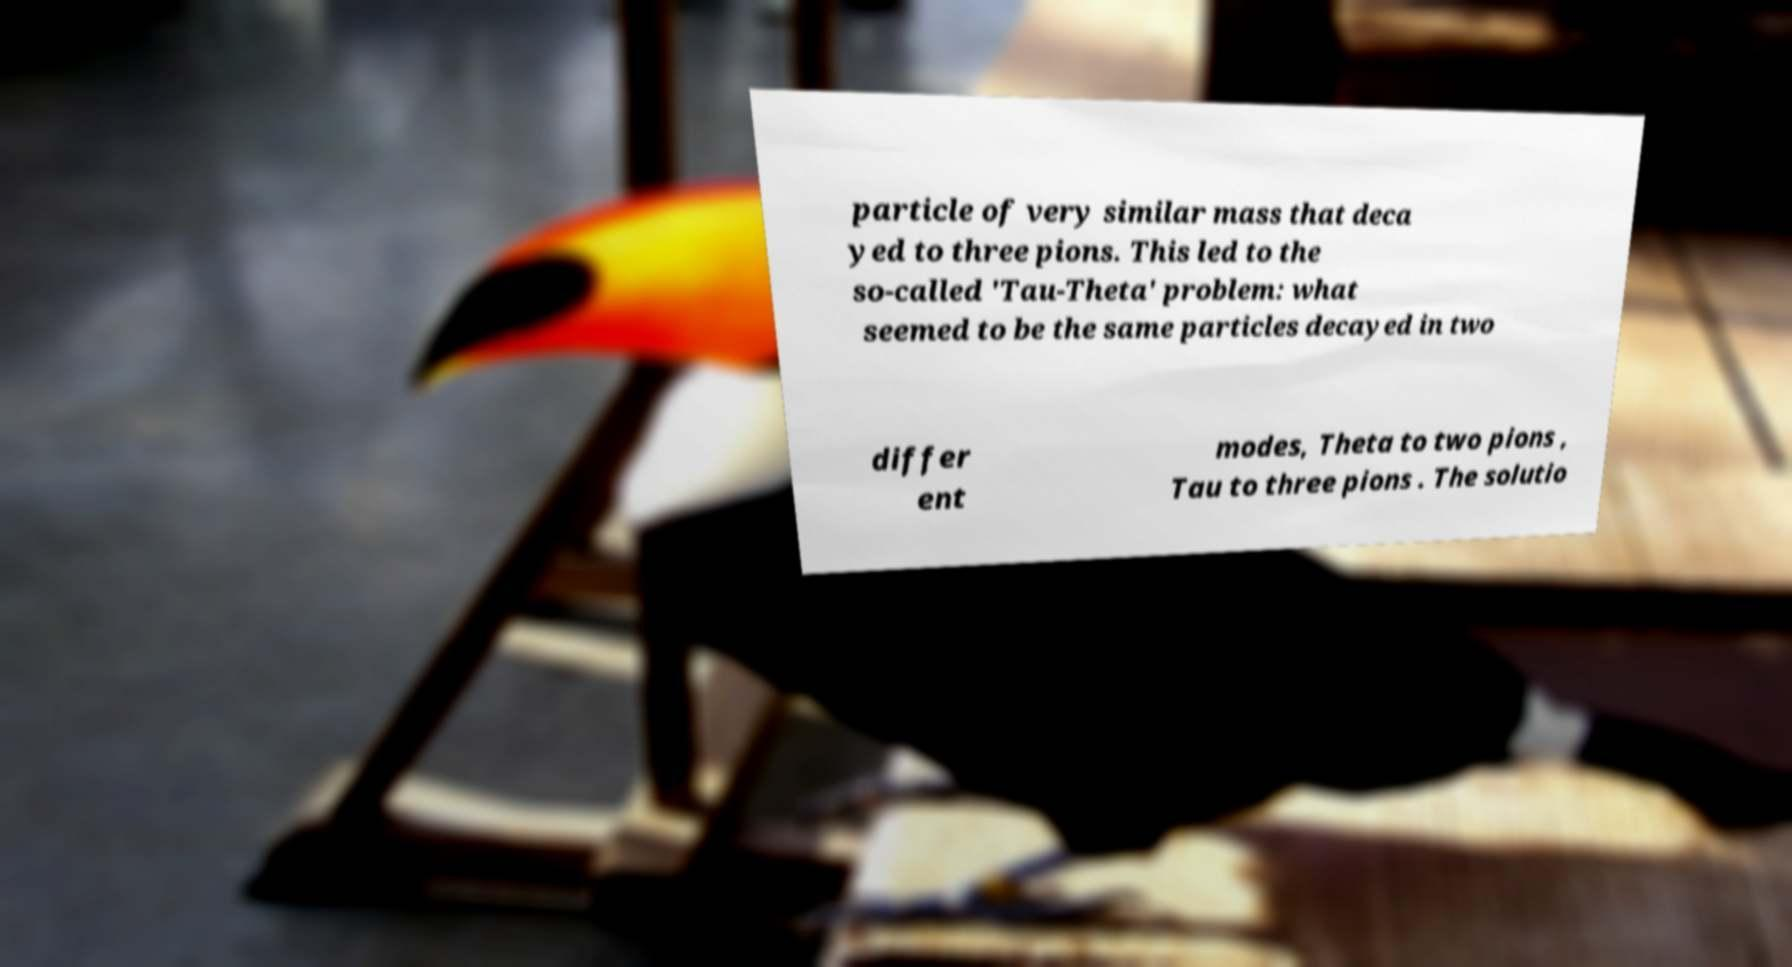Can you read and provide the text displayed in the image?This photo seems to have some interesting text. Can you extract and type it out for me? particle of very similar mass that deca yed to three pions. This led to the so-called 'Tau-Theta' problem: what seemed to be the same particles decayed in two differ ent modes, Theta to two pions , Tau to three pions . The solutio 